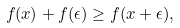<formula> <loc_0><loc_0><loc_500><loc_500>f ( x ) + f ( \epsilon ) \geq f ( x + \epsilon ) ,</formula> 